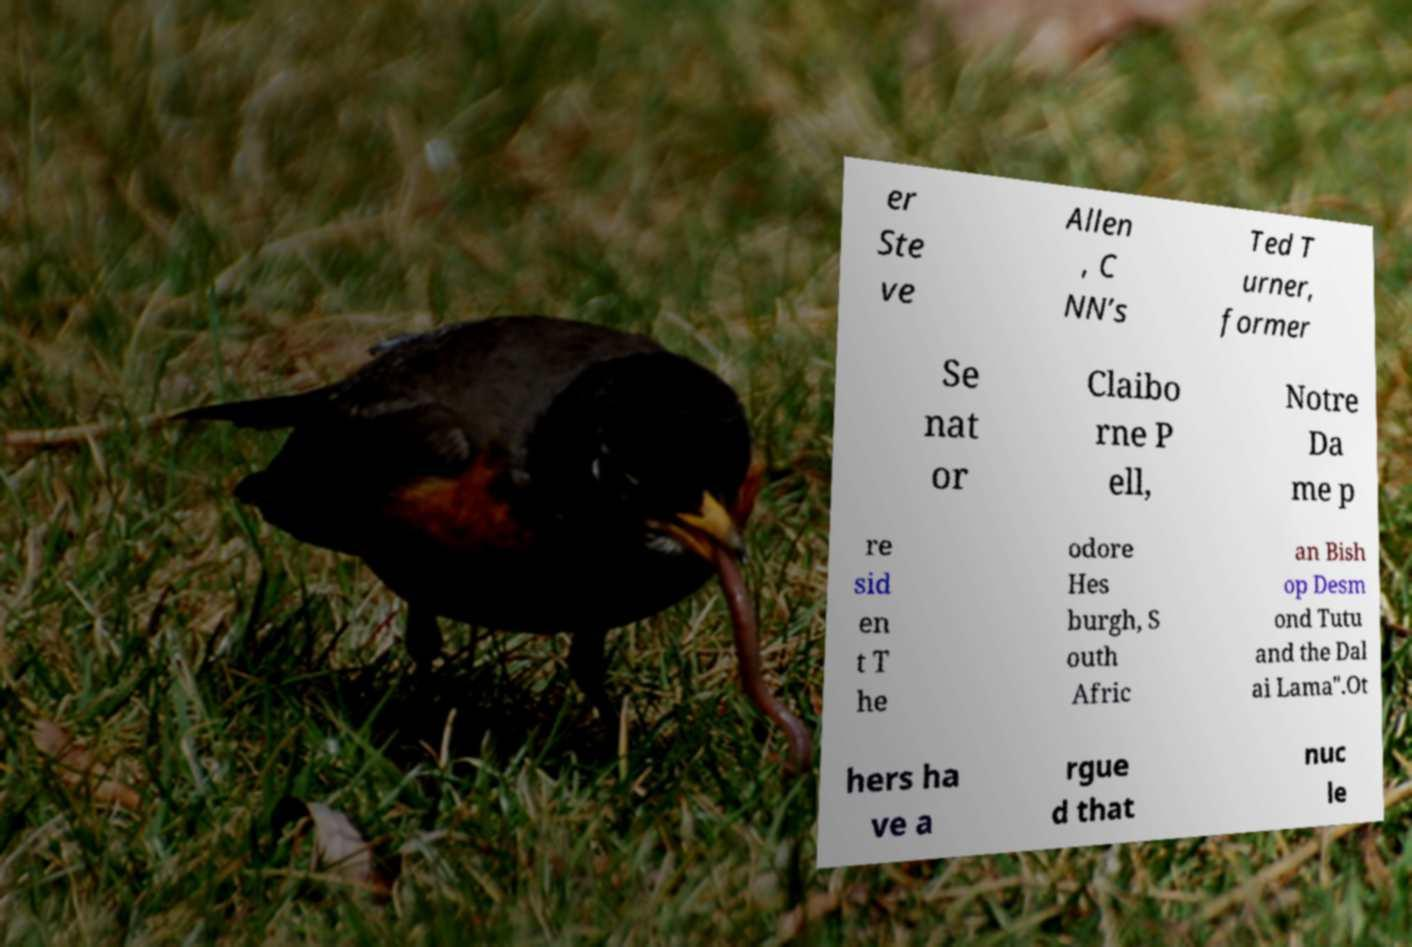Could you extract and type out the text from this image? er Ste ve Allen , C NN’s Ted T urner, former Se nat or Claibo rne P ell, Notre Da me p re sid en t T he odore Hes burgh, S outh Afric an Bish op Desm ond Tutu and the Dal ai Lama".Ot hers ha ve a rgue d that nuc le 